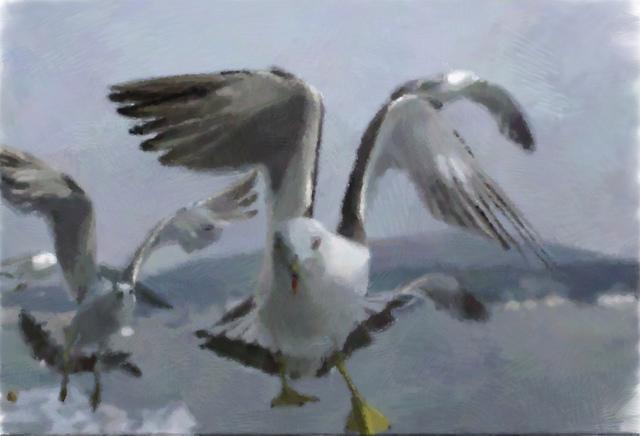What is a group of these animals called?
Answer briefly. Flock. What setting is the background?
Concise answer only. Mountains. Is this a painting or a photograph?
Be succinct. Painting. 